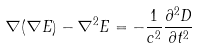<formula> <loc_0><loc_0><loc_500><loc_500>\nabla ( \nabla { E } ) - \nabla ^ { 2 } { E } = - \frac { 1 } { c ^ { 2 } } \frac { { \partial } ^ { 2 } { D } } { \partial t ^ { 2 } }</formula> 